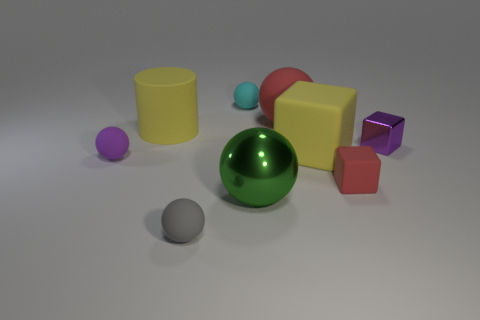Subtract all green spheres. How many spheres are left? 4 Subtract all large shiny spheres. How many spheres are left? 4 Add 1 red blocks. How many objects exist? 10 Subtract all blue balls. Subtract all purple cylinders. How many balls are left? 5 Subtract all cylinders. How many objects are left? 8 Add 1 big green metallic things. How many big green metallic things are left? 2 Add 6 big gray shiny cubes. How many big gray shiny cubes exist? 6 Subtract 0 blue balls. How many objects are left? 9 Subtract all tiny metallic cubes. Subtract all tiny red cubes. How many objects are left? 7 